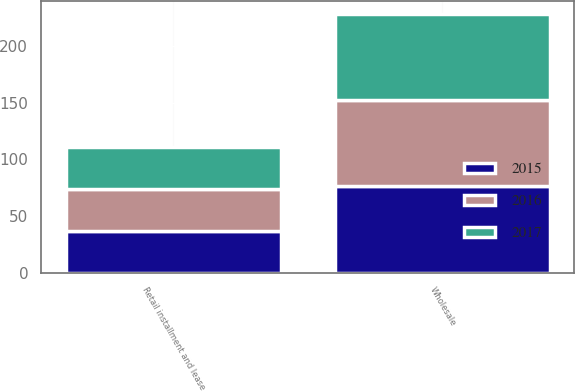Convert chart to OTSL. <chart><loc_0><loc_0><loc_500><loc_500><stacked_bar_chart><ecel><fcel>Retail installment and lease<fcel>Wholesale<nl><fcel>2016<fcel>37<fcel>76<nl><fcel>2015<fcel>37<fcel>76<nl><fcel>2017<fcel>37<fcel>76<nl></chart> 